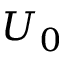<formula> <loc_0><loc_0><loc_500><loc_500>U _ { 0 }</formula> 